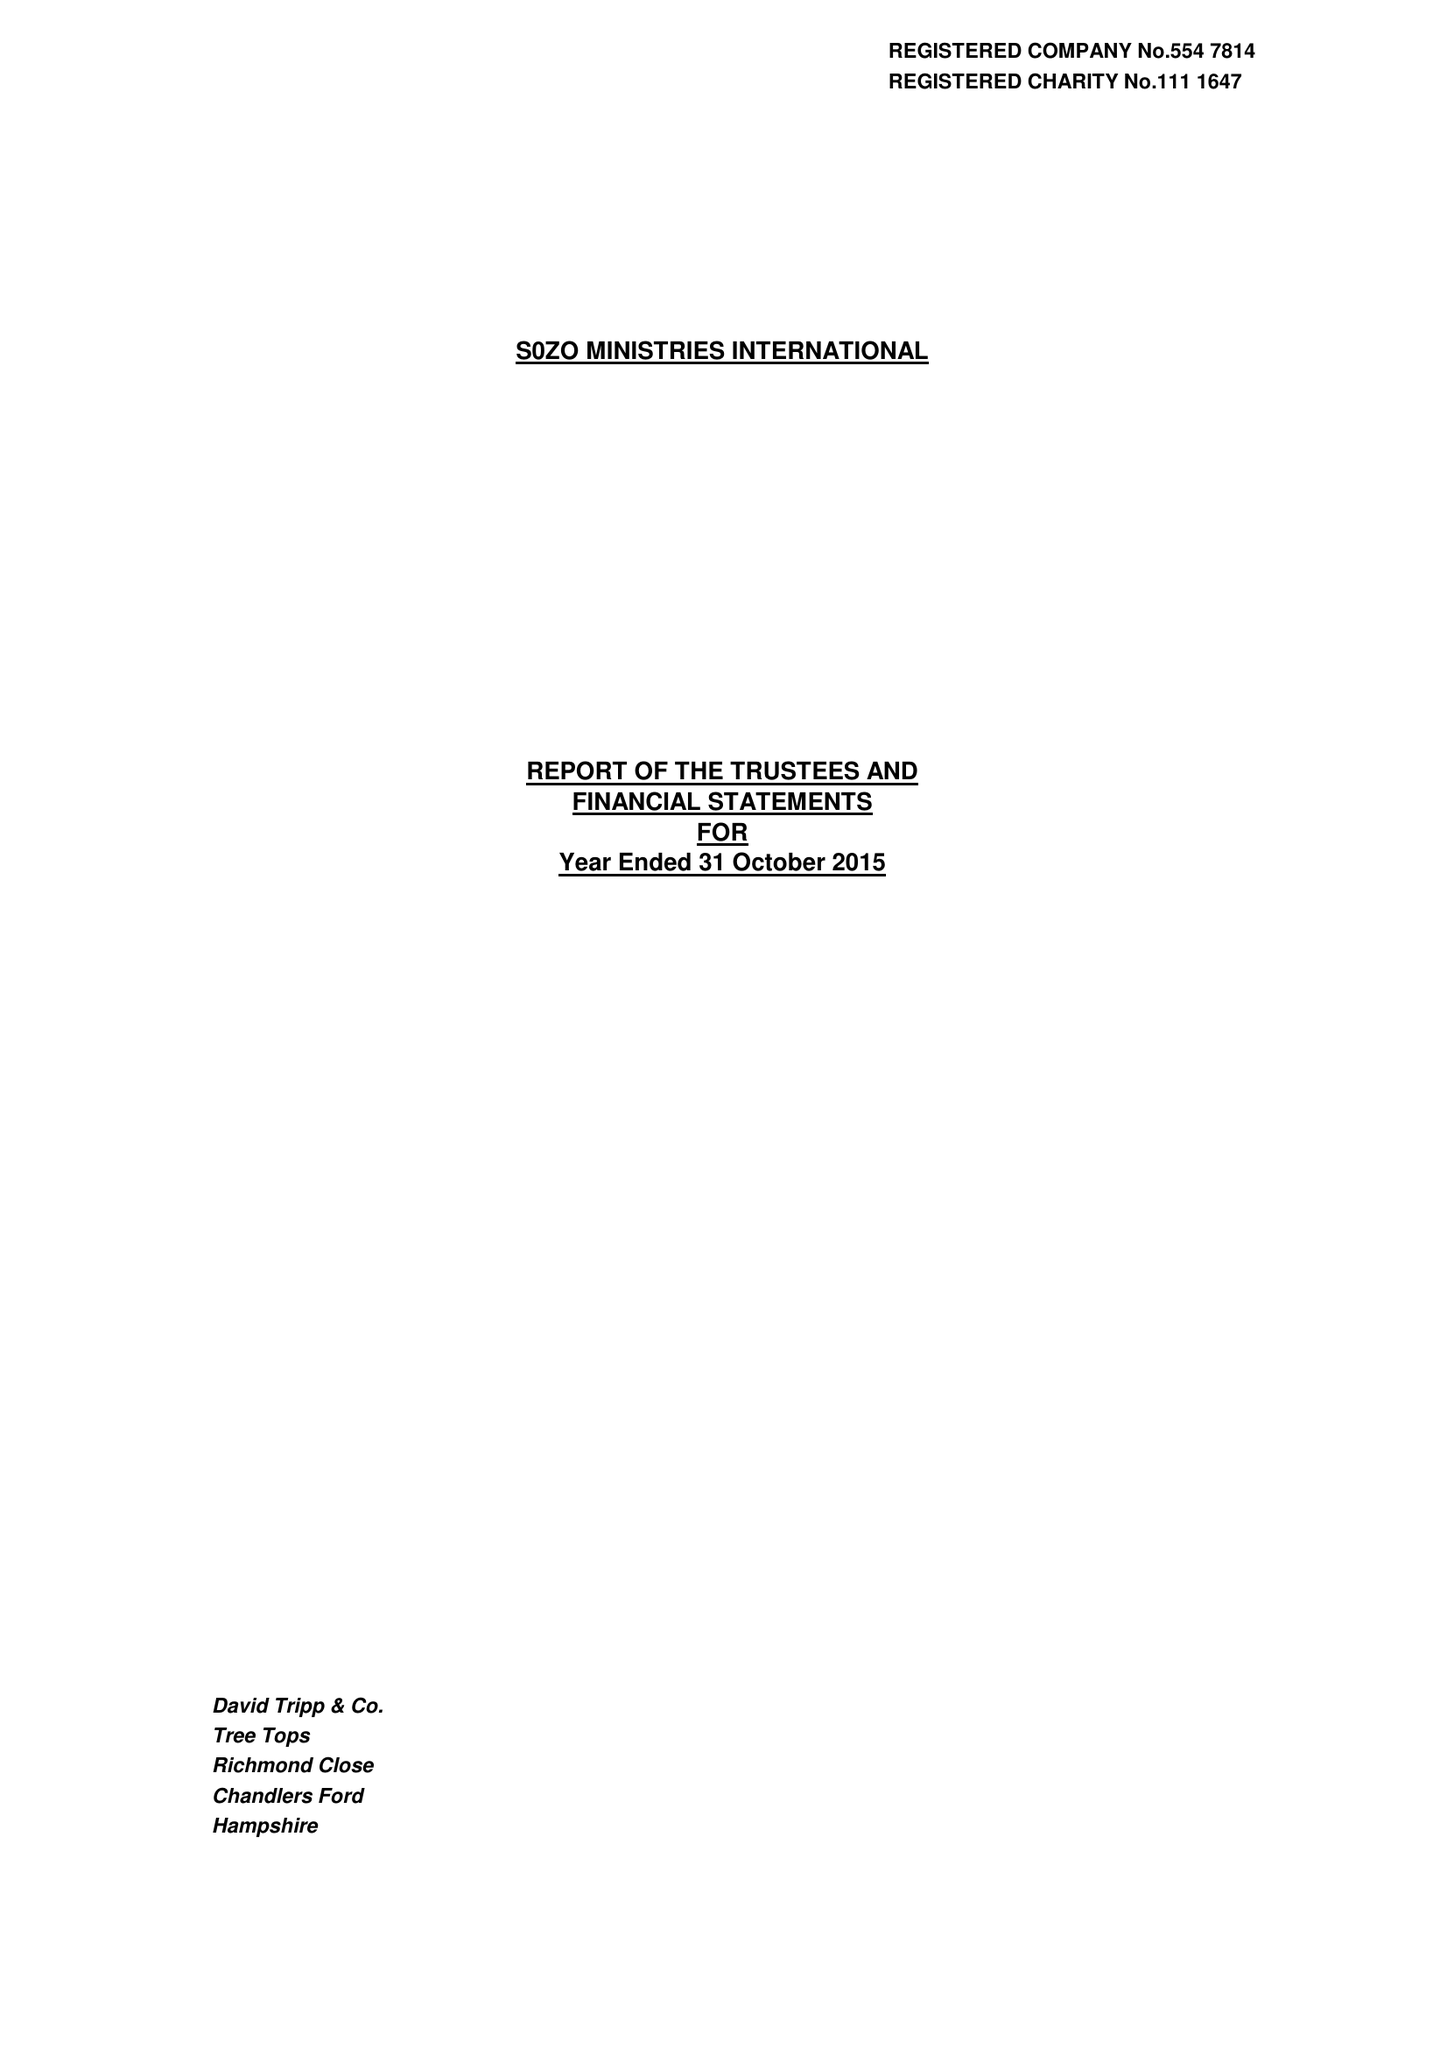What is the value for the address__street_line?
Answer the question using a single word or phrase. DANES ROAD 